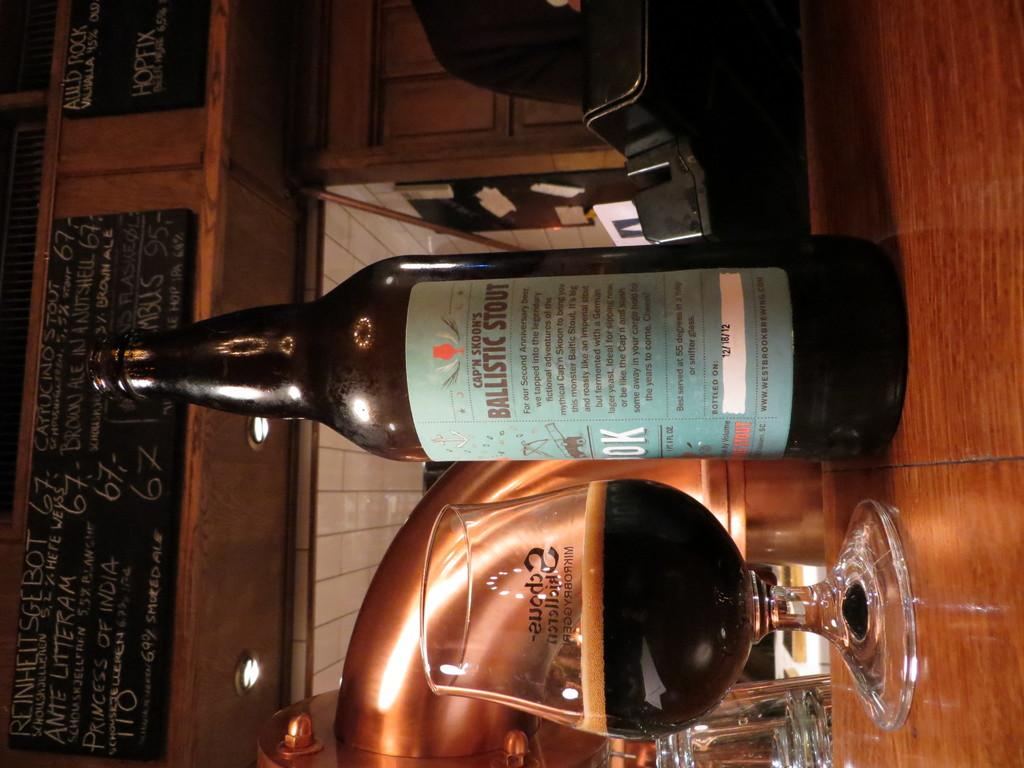What type of alcoholic beverage is featured in the image? There is a scotch bottle in the image. What is the glass filled with in the image? There is a glass filled with a drink in the image. Can you describe the background of the image? The background includes a glass, a wall with rates written on it, and lights. What advice is given on the map in the image? There is no map present in the image, so no advice can be given. Is there a fight happening in the image? There is no indication of a fight in the image; it features a scotch bottle, a glass filled with a drink, and a background with a glass, a wall with rates written on it, and lights. 